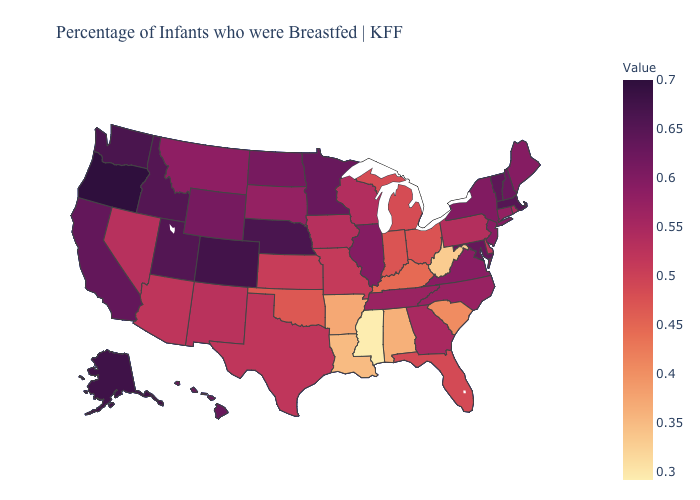Which states have the lowest value in the South?
Give a very brief answer. Mississippi. Which states have the lowest value in the Northeast?
Short answer required. Pennsylvania. Is the legend a continuous bar?
Give a very brief answer. Yes. Does Iowa have the lowest value in the USA?
Give a very brief answer. No. Does Mississippi have the lowest value in the USA?
Write a very short answer. Yes. Among the states that border Minnesota , does North Dakota have the highest value?
Short answer required. Yes. Does Oregon have the highest value in the USA?
Give a very brief answer. Yes. Is the legend a continuous bar?
Answer briefly. Yes. 